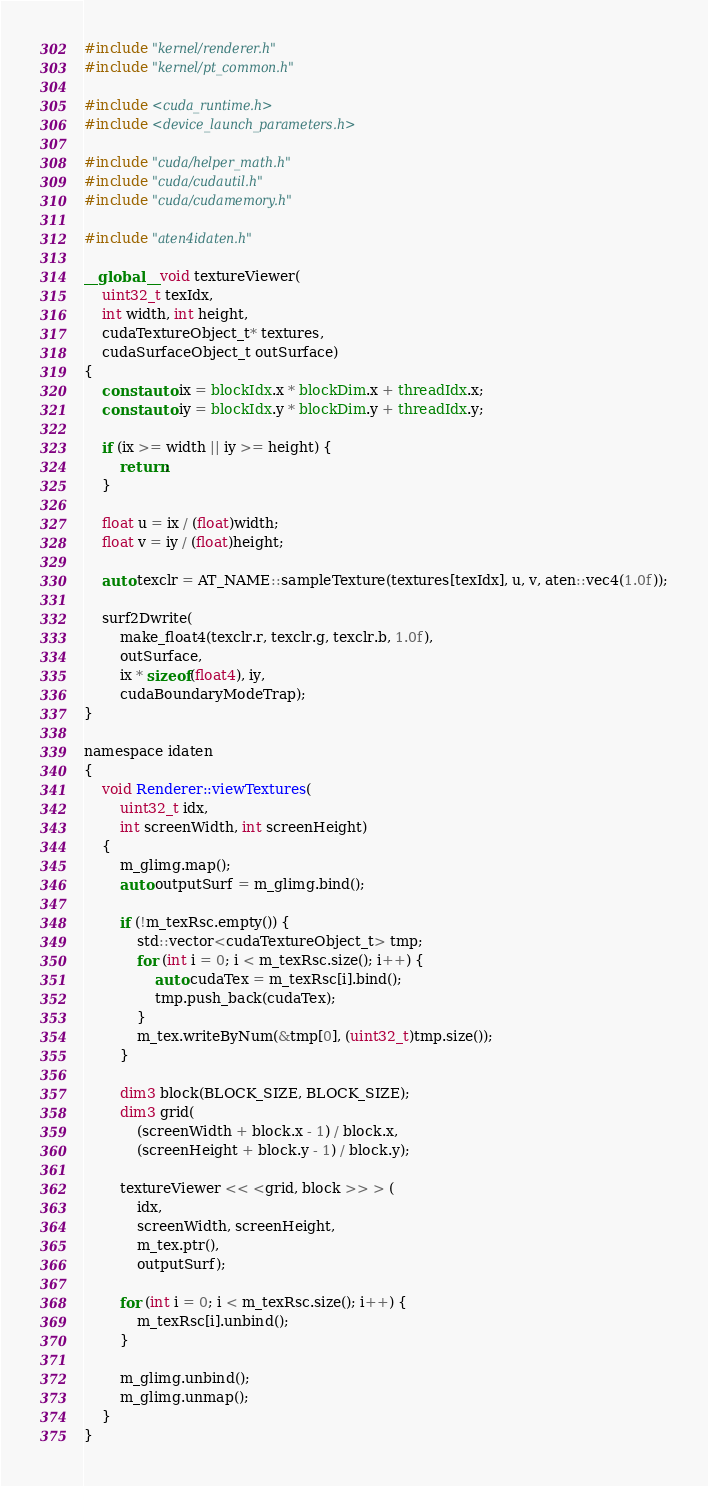<code> <loc_0><loc_0><loc_500><loc_500><_Cuda_>#include "kernel/renderer.h"
#include "kernel/pt_common.h"

#include <cuda_runtime.h>
#include <device_launch_parameters.h>

#include "cuda/helper_math.h"
#include "cuda/cudautil.h"
#include "cuda/cudamemory.h"

#include "aten4idaten.h"

__global__ void textureViewer(
    uint32_t texIdx,
    int width, int height,
    cudaTextureObject_t* textures,
    cudaSurfaceObject_t outSurface)
{
    const auto ix = blockIdx.x * blockDim.x + threadIdx.x;
    const auto iy = blockIdx.y * blockDim.y + threadIdx.y;

    if (ix >= width || iy >= height) {
        return;
    }

    float u = ix / (float)width;
    float v = iy / (float)height;

    auto texclr = AT_NAME::sampleTexture(textures[texIdx], u, v, aten::vec4(1.0f));

    surf2Dwrite(
        make_float4(texclr.r, texclr.g, texclr.b, 1.0f),
        outSurface,
        ix * sizeof(float4), iy,
        cudaBoundaryModeTrap);
}

namespace idaten
{
    void Renderer::viewTextures(
        uint32_t idx,
        int screenWidth, int screenHeight)
    {
        m_glimg.map();
        auto outputSurf = m_glimg.bind();

        if (!m_texRsc.empty()) {
            std::vector<cudaTextureObject_t> tmp;
            for (int i = 0; i < m_texRsc.size(); i++) {
                auto cudaTex = m_texRsc[i].bind();
                tmp.push_back(cudaTex);
            }
            m_tex.writeByNum(&tmp[0], (uint32_t)tmp.size());
        }

        dim3 block(BLOCK_SIZE, BLOCK_SIZE);
        dim3 grid(
            (screenWidth + block.x - 1) / block.x,
            (screenHeight + block.y - 1) / block.y);

        textureViewer << <grid, block >> > (
            idx,
            screenWidth, screenHeight,
            m_tex.ptr(),
            outputSurf);

        for (int i = 0; i < m_texRsc.size(); i++) {
            m_texRsc[i].unbind();
        }

        m_glimg.unbind();
        m_glimg.unmap();
    }
}
</code> 